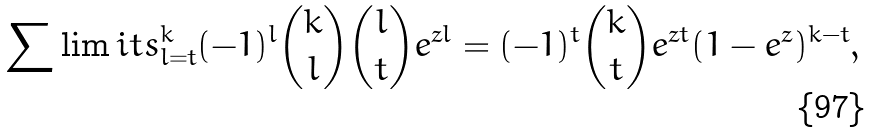Convert formula to latex. <formula><loc_0><loc_0><loc_500><loc_500>\sum \lim i t s _ { l = t } ^ { k } ( - 1 ) ^ { l } \binom { k } { l } \binom { l } { t } e ^ { z l } = ( - 1 ) ^ { t } \binom { k } { t } e ^ { z t } ( 1 - e ^ { z } ) ^ { k - t } ,</formula> 